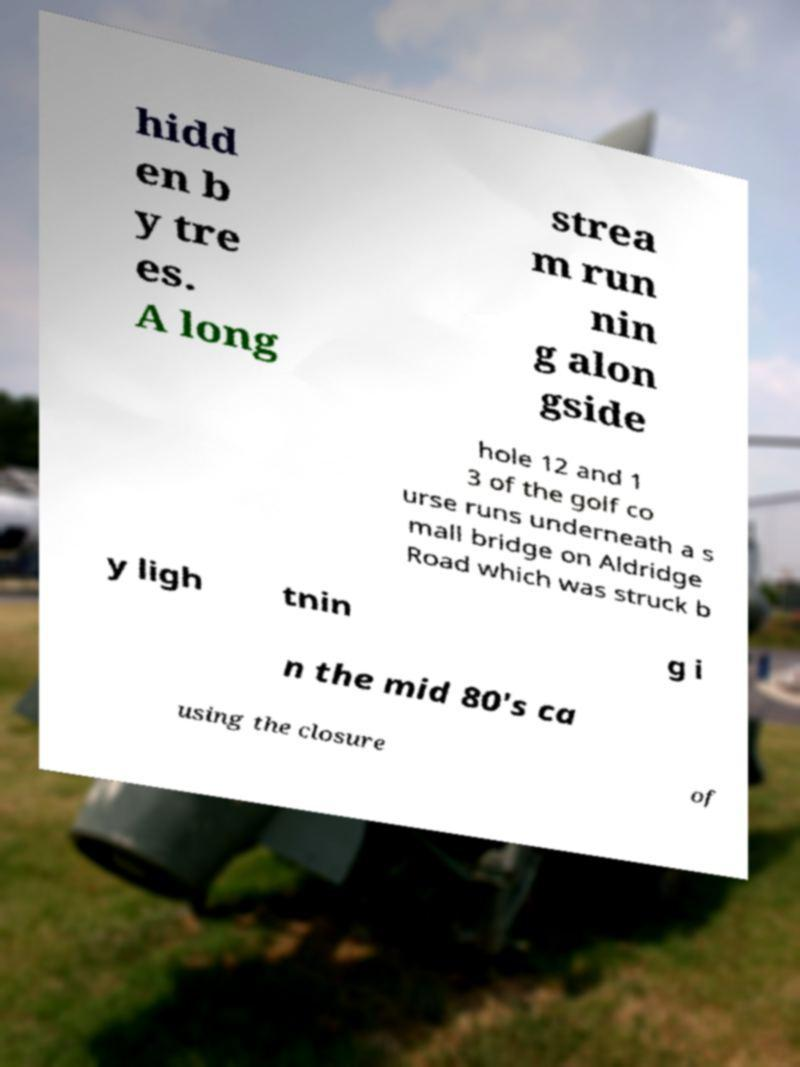Can you read and provide the text displayed in the image?This photo seems to have some interesting text. Can you extract and type it out for me? hidd en b y tre es. A long strea m run nin g alon gside hole 12 and 1 3 of the golf co urse runs underneath a s mall bridge on Aldridge Road which was struck b y ligh tnin g i n the mid 80's ca using the closure of 